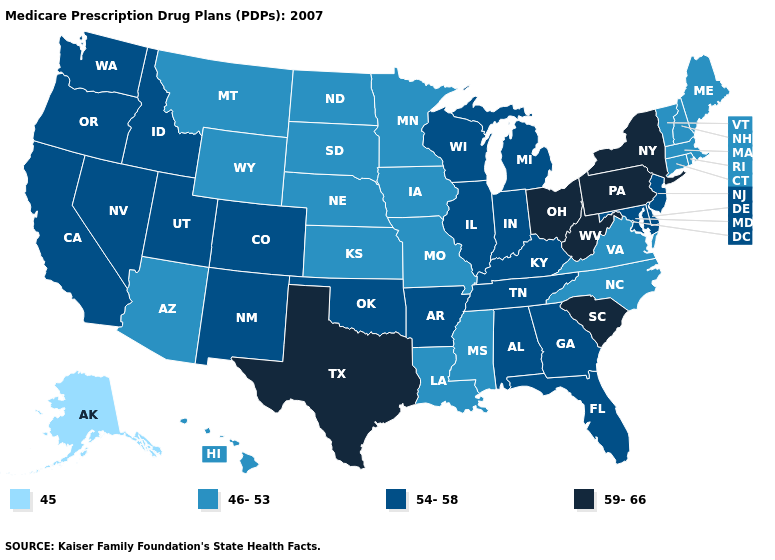Name the states that have a value in the range 54-58?
Keep it brief. Alabama, Arkansas, California, Colorado, Delaware, Florida, Georgia, Idaho, Illinois, Indiana, Kentucky, Maryland, Michigan, New Jersey, New Mexico, Nevada, Oklahoma, Oregon, Tennessee, Utah, Washington, Wisconsin. Name the states that have a value in the range 45?
Be succinct. Alaska. What is the value of Rhode Island?
Give a very brief answer. 46-53. What is the value of California?
Give a very brief answer. 54-58. What is the highest value in the South ?
Give a very brief answer. 59-66. Which states have the highest value in the USA?
Answer briefly. New York, Ohio, Pennsylvania, South Carolina, Texas, West Virginia. Does Louisiana have the same value as Wyoming?
Write a very short answer. Yes. How many symbols are there in the legend?
Quick response, please. 4. What is the value of Florida?
Answer briefly. 54-58. What is the value of Louisiana?
Keep it brief. 46-53. Name the states that have a value in the range 46-53?
Keep it brief. Arizona, Connecticut, Hawaii, Iowa, Kansas, Louisiana, Massachusetts, Maine, Minnesota, Missouri, Mississippi, Montana, North Carolina, North Dakota, Nebraska, New Hampshire, Rhode Island, South Dakota, Virginia, Vermont, Wyoming. Among the states that border California , which have the highest value?
Be succinct. Nevada, Oregon. Does Wyoming have the same value as Pennsylvania?
Give a very brief answer. No. What is the lowest value in the USA?
Write a very short answer. 45. What is the value of Louisiana?
Quick response, please. 46-53. 